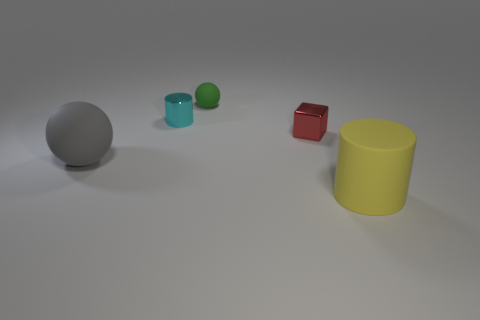The big rubber object that is to the right of the big rubber object that is to the left of the cylinder to the right of the tiny cyan shiny thing is what shape? The object in question, which lies to the right of the big rubber object that is to the left of the yellow cylinder, and also to the right of a tiny cyan glossy object, is a sphere. Specifically, it’s a grey sphere of a considerable size juxtaposed against a lighter surface. 